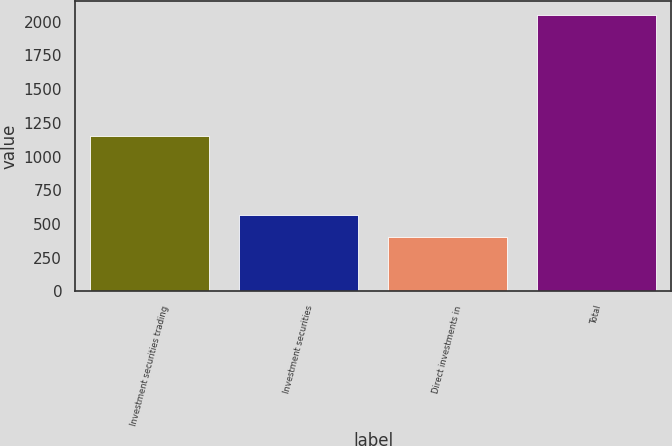Convert chart. <chart><loc_0><loc_0><loc_500><loc_500><bar_chart><fcel>Investment securities trading<fcel>Investment securities<fcel>Direct investments in<fcel>Total<nl><fcel>1149.8<fcel>566.35<fcel>401.5<fcel>2050<nl></chart> 